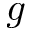<formula> <loc_0><loc_0><loc_500><loc_500>g</formula> 